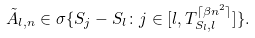<formula> <loc_0><loc_0><loc_500><loc_500>\tilde { A } _ { l , n } \in \sigma \{ S _ { j } - S _ { l } \colon j \in [ l , T _ { S _ { l } , l } ^ { \lceil \beta n ^ { 2 } \rceil } ] \} .</formula> 